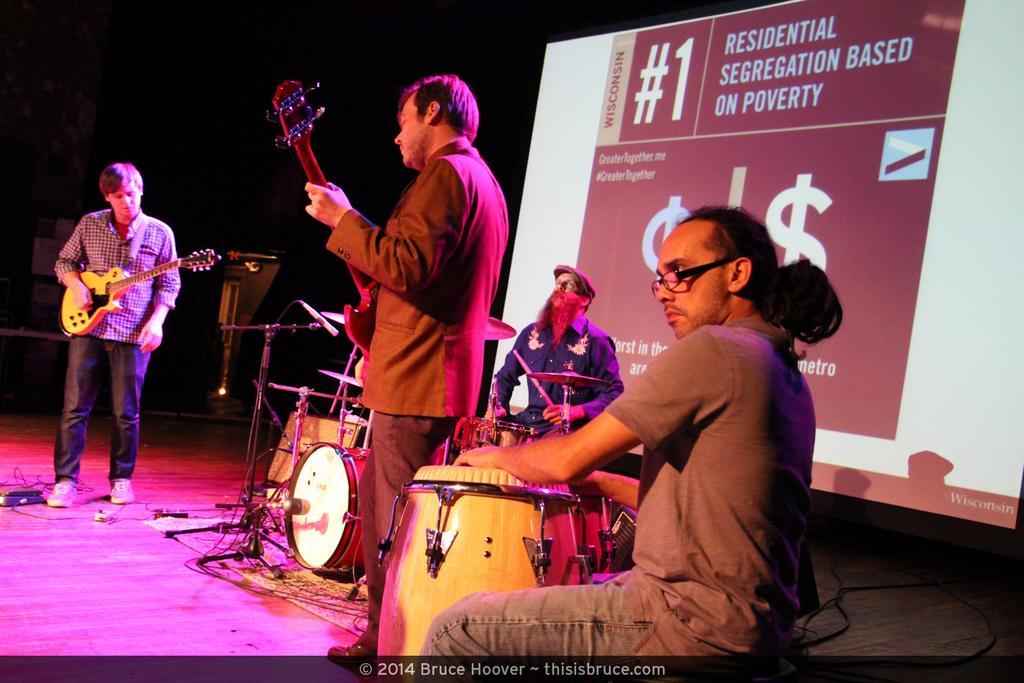Can you describe this image briefly? In the image we can see there are four people two of them are standing and two of them are sitting. This is a musical band. This is a guitar and a poster. 